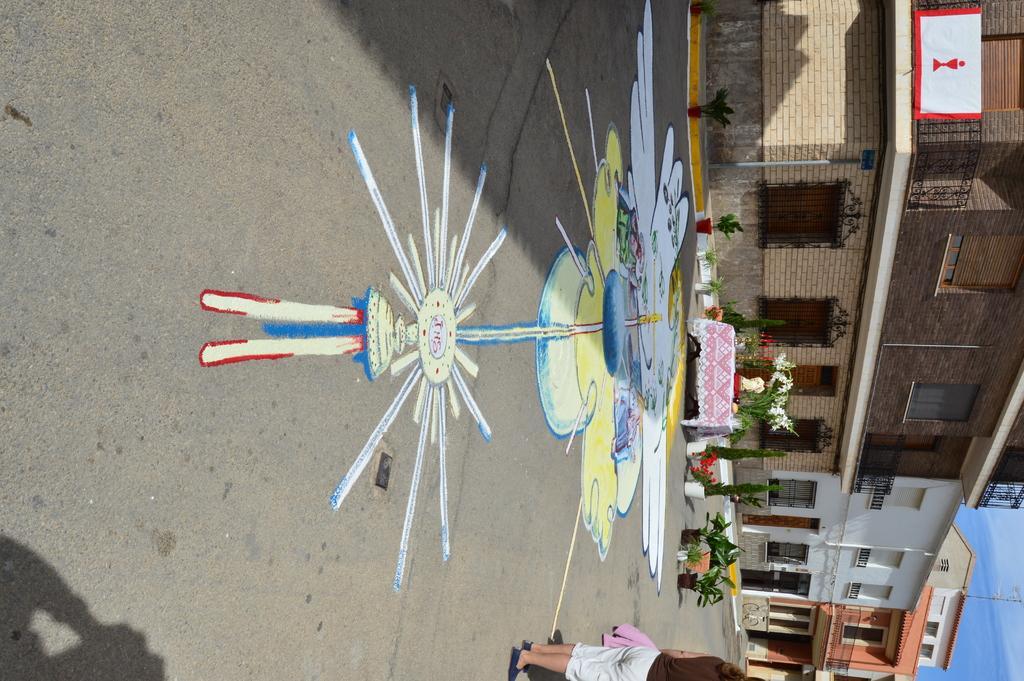Describe this image in one or two sentences. In this picture we can see some buildings, in front we can see the road on which we can see painting, potted plants, and table with few objects. 